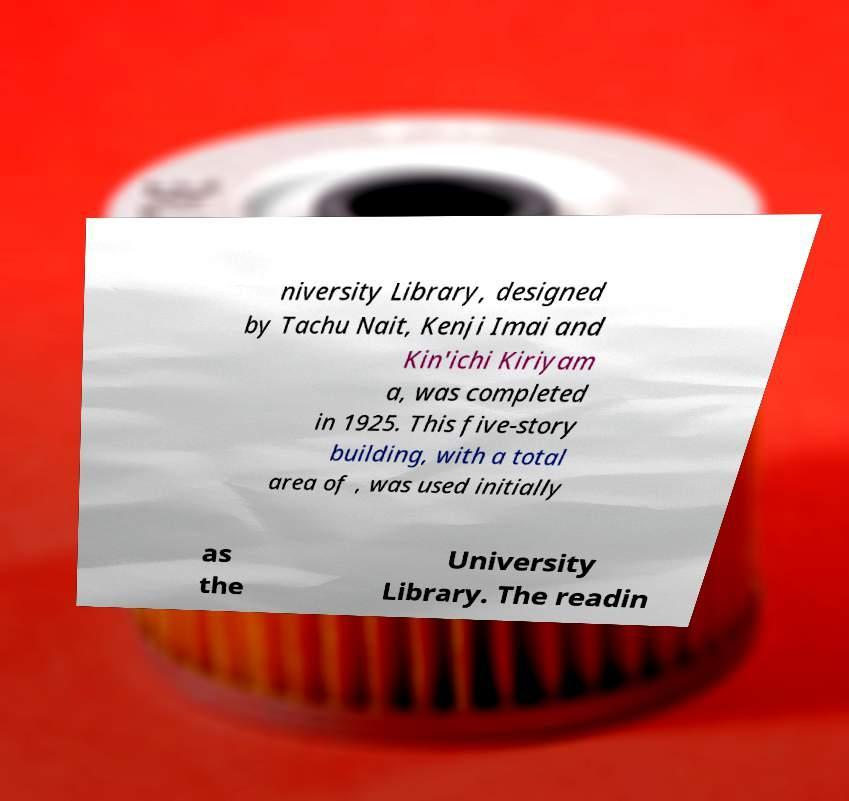Please read and relay the text visible in this image. What does it say? niversity Library, designed by Tachu Nait, Kenji Imai and Kin'ichi Kiriyam a, was completed in 1925. This five-story building, with a total area of , was used initially as the University Library. The readin 